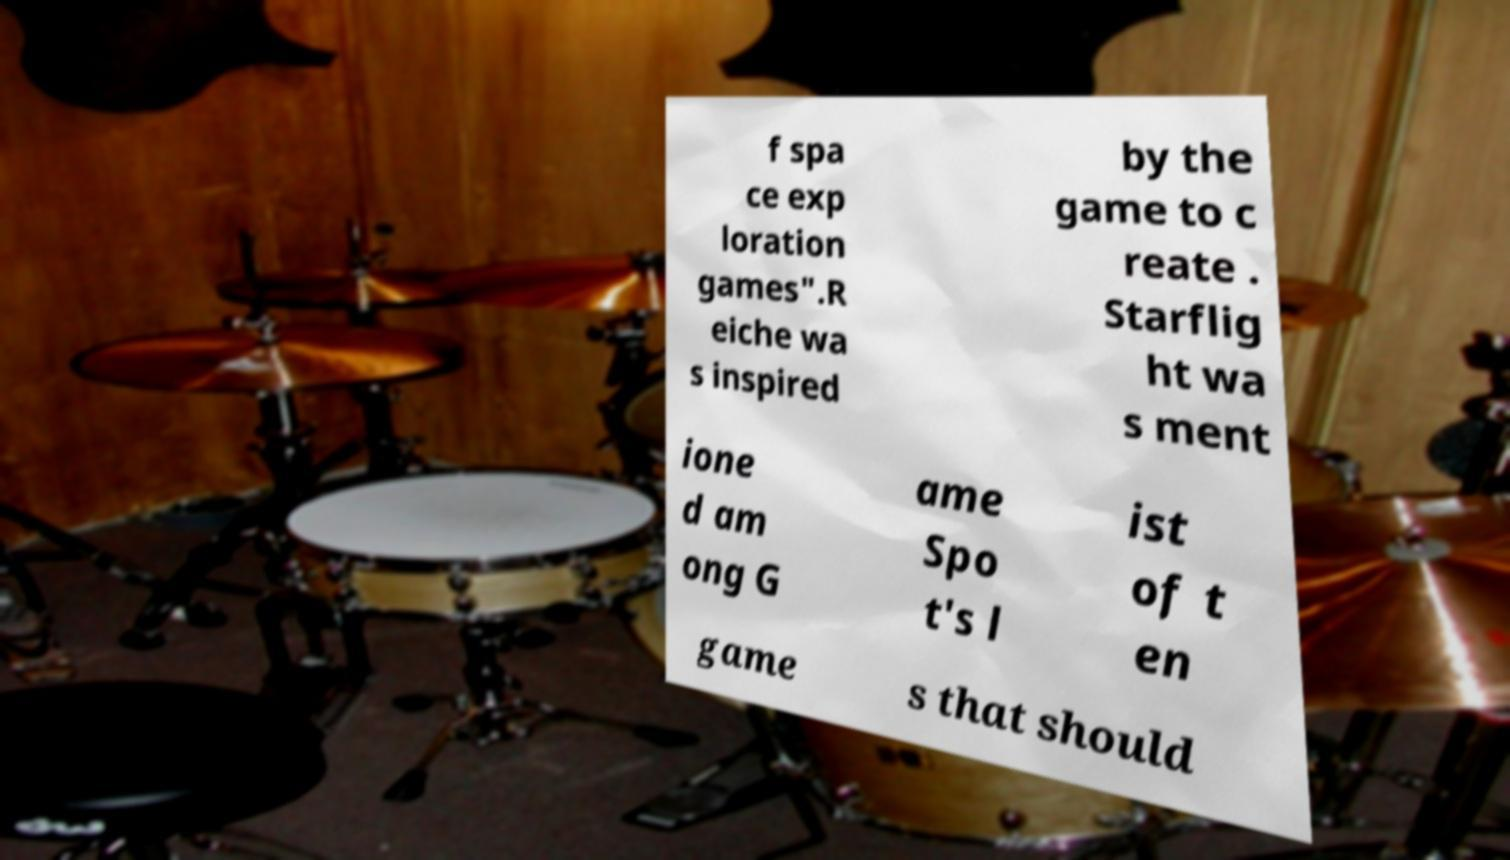Could you extract and type out the text from this image? f spa ce exp loration games".R eiche wa s inspired by the game to c reate . Starflig ht wa s ment ione d am ong G ame Spo t's l ist of t en game s that should 